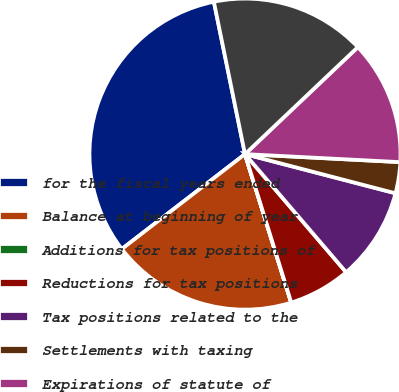Convert chart to OTSL. <chart><loc_0><loc_0><loc_500><loc_500><pie_chart><fcel>for the fiscal years ended<fcel>Balance at beginning of year<fcel>Additions for tax positions of<fcel>Reductions for tax positions<fcel>Tax positions related to the<fcel>Settlements with taxing<fcel>Expirations of statute of<fcel>Balance at End of Year<nl><fcel>32.24%<fcel>19.35%<fcel>0.01%<fcel>6.46%<fcel>9.68%<fcel>3.23%<fcel>12.9%<fcel>16.13%<nl></chart> 